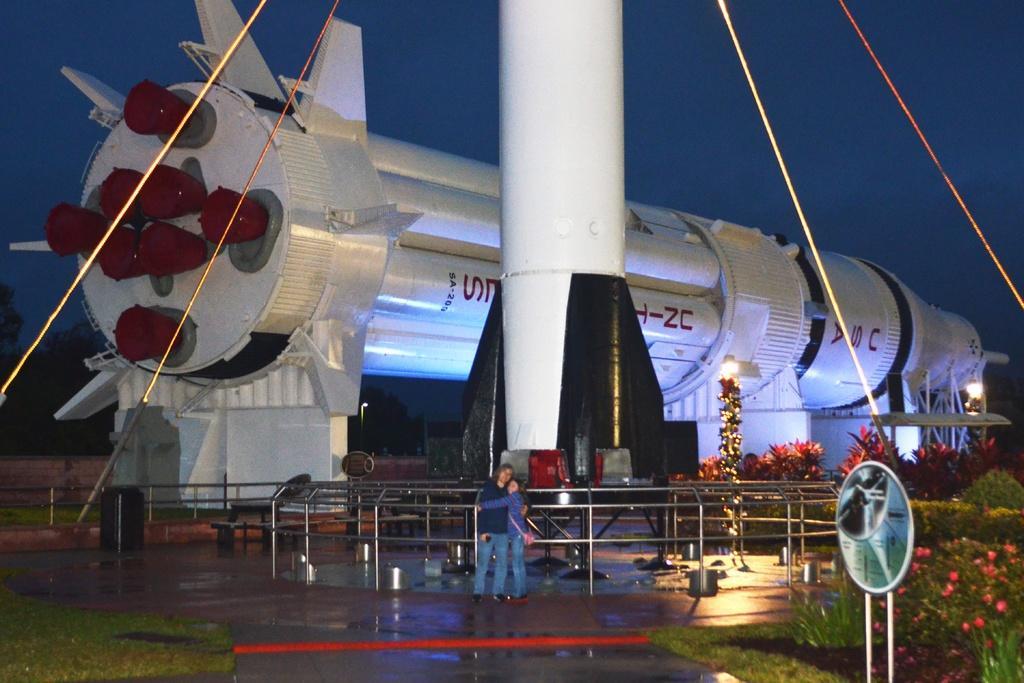How would you summarize this image in a sentence or two? In the picture we can see a rocket which is white in color and placed on the stands and near it we can see a railing and a rocket pole with some ropes tied to it and near the railing we can see a man and a woman are standing together and near to them we can see a grass surface with some plants and flowers to it, and in the background we can see a sky. 